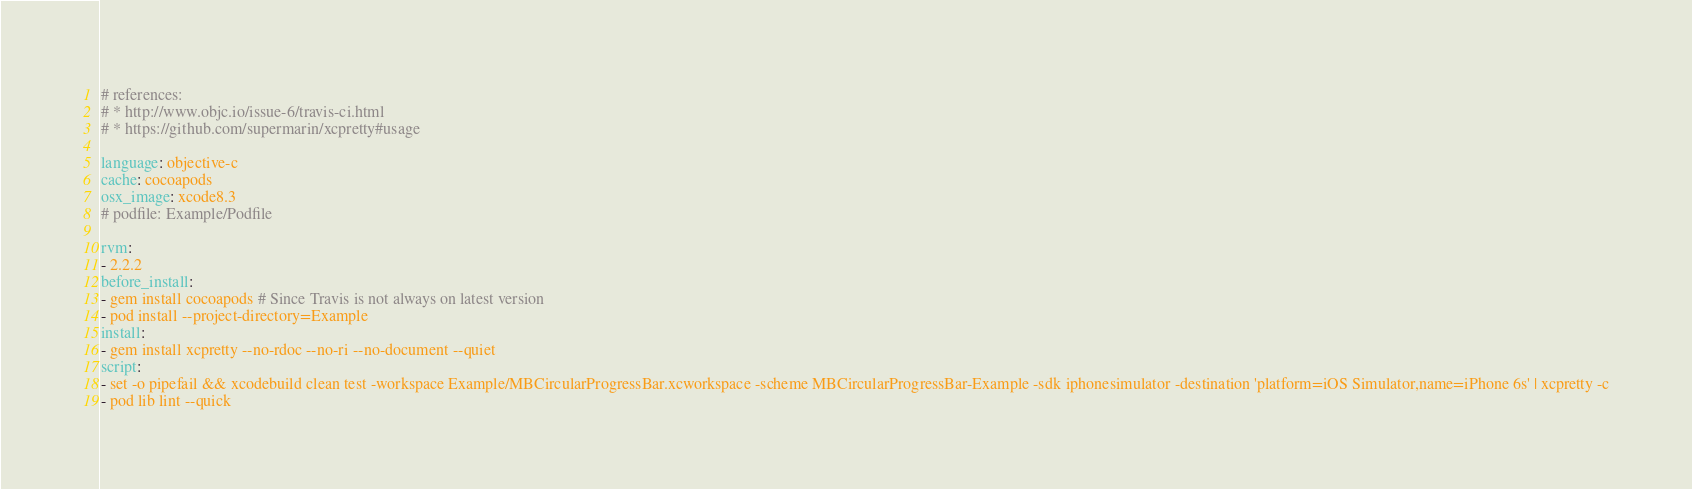Convert code to text. <code><loc_0><loc_0><loc_500><loc_500><_YAML_># references:
# * http://www.objc.io/issue-6/travis-ci.html
# * https://github.com/supermarin/xcpretty#usage

language: objective-c
cache: cocoapods
osx_image: xcode8.3
# podfile: Example/Podfile

rvm:
- 2.2.2
before_install:
- gem install cocoapods # Since Travis is not always on latest version
- pod install --project-directory=Example
install:
- gem install xcpretty --no-rdoc --no-ri --no-document --quiet
script:
- set -o pipefail && xcodebuild clean test -workspace Example/MBCircularProgressBar.xcworkspace -scheme MBCircularProgressBar-Example -sdk iphonesimulator -destination 'platform=iOS Simulator,name=iPhone 6s' | xcpretty -c
- pod lib lint --quick
</code> 